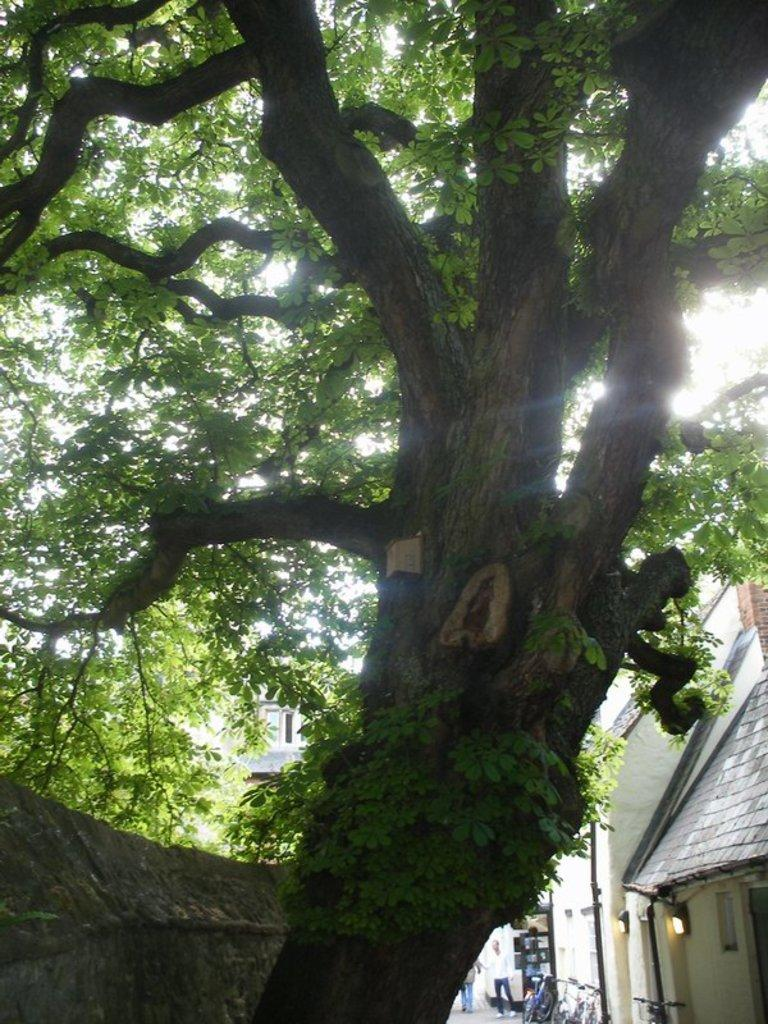What is the main object in the foreground of the image? There is a tree in the image. What can be seen in the background of the image? There are houses, two persons, bicycles, poles, a light on the wall, windows, and the sky visible in the background of the image. What type of toothpaste is being used by the persons in the image? There is no toothpaste present in the image; it features a tree in the foreground and various elements in the background. 